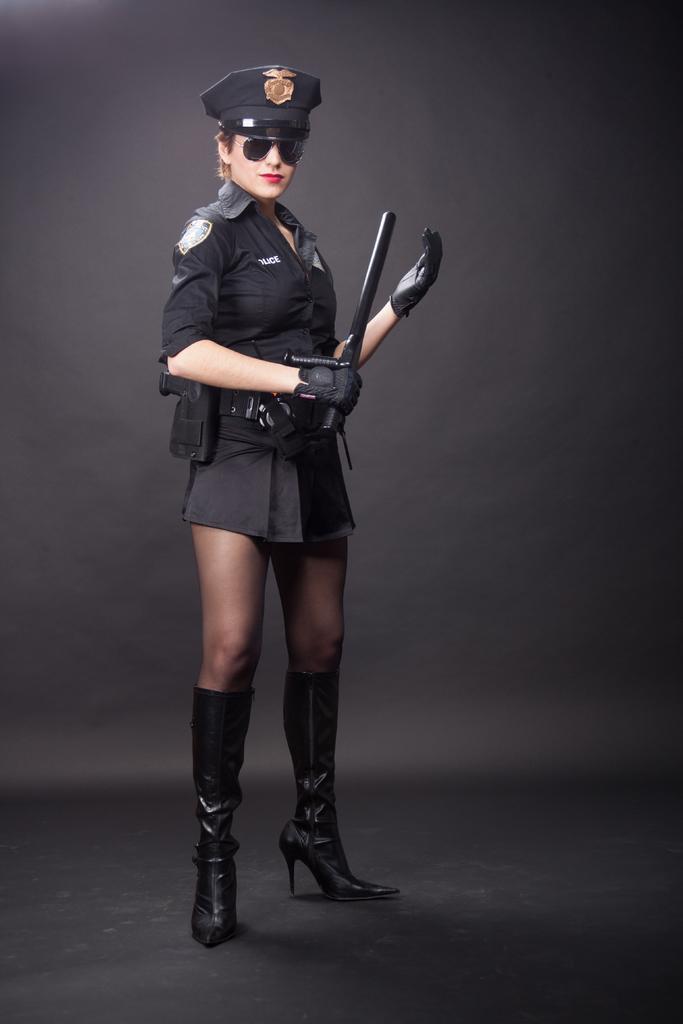How would you summarize this image in a sentence or two? Here we can see a woman standing on the floor. She has goggles and she is holding a gun with her hand. 